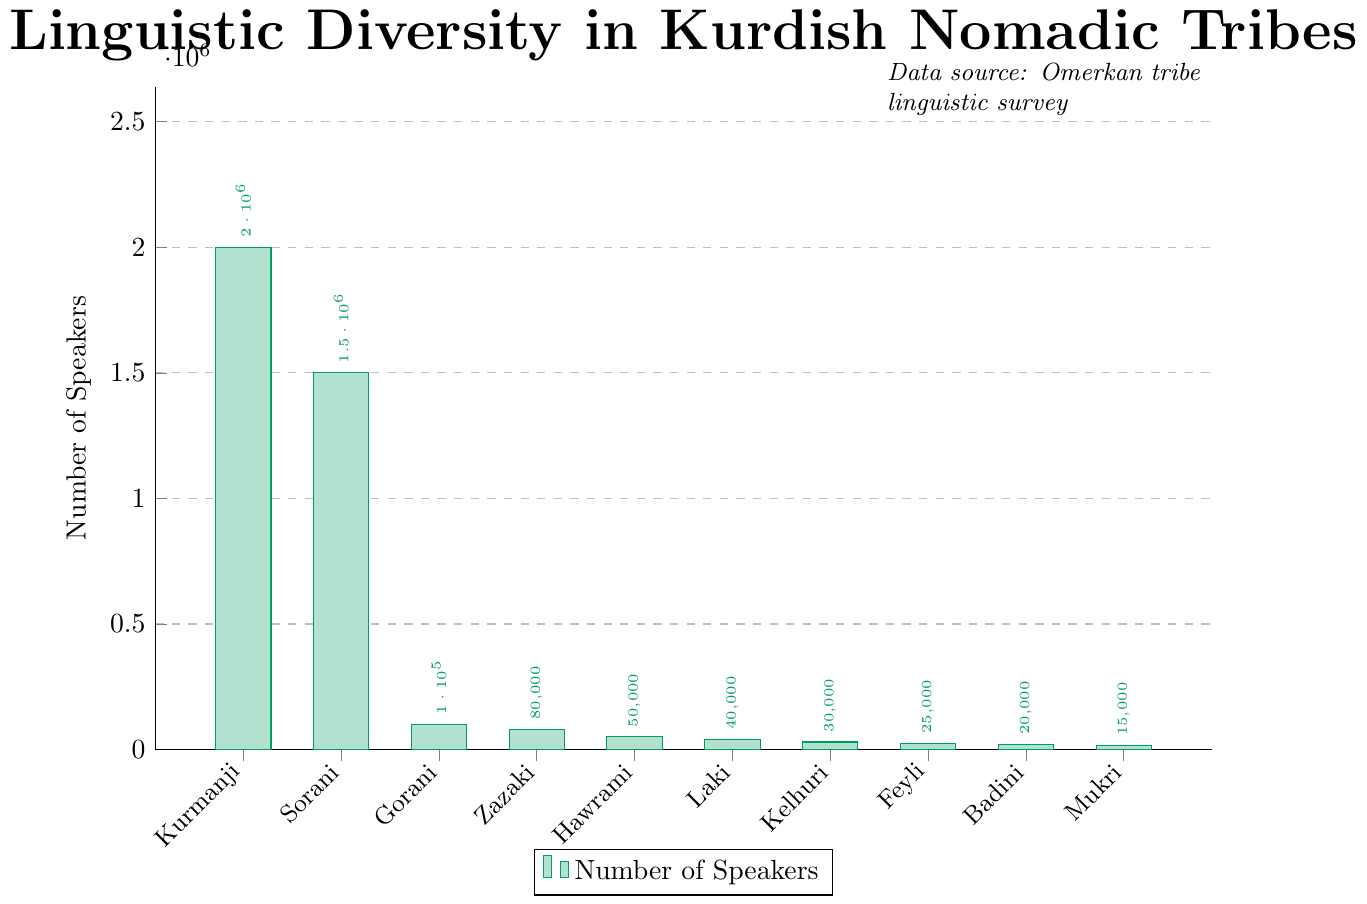Which dialect has the highest number of speakers? The bar representing Kurmanji is the tallest among all the bars, indicating it has the highest number of speakers.
Answer: Kurmanji How many more speakers does Sorani have compared to Gorani? The number of speakers for Sorani is 1,500,000, and for Gorani, it is 100,000. Subtracting Gorani's speakers from Sorani's gives 1,500,000 - 100,000.
Answer: 1,400,000 Which dialects have fewer than 50,000 speakers? The bars representing Hawrami, Laki, Kelhuri, Feyli, Badini, and Mukri are below the 50,000 mark on the y-axis.
Answer: Hawrami, Laki, Kelhuri, Feyli, Badini, Mukri What is the total number of speakers for the least spoken three dialects? The least spoken three dialects are Mukri, Badini, and Feyli with 15,000, 20,000, and 25,000 speakers respectively. Summing these values gives 15,000 + 20,000 + 25,000 = 60,000.
Answer: 60,000 Which dialect represents the second highest number of speakers? The bar representing Sorani is the second tallest after Kurmanji, indicating it has the second highest number of speakers.
Answer: Sorani Is the number of Gorani speakers greater than the combined speakers of Feyli and Mukri? Gorani has 100,000 speakers. Feyli has 25,000, and Mukri has 15,000. Combining Feyli and Mukri gives 25,000 + 15,000 = 40,000. Since 100,000 is greater than 40,000, the answer is yes.
Answer: Yes What is the average number of speakers for the dialects Hawrami, Laki, and Kelhuri? The number of speakers for Hawrami, Laki, and Kelhuri are 50,000, 40,000, and 30,000 respectively. Summing these and dividing by 3 gives (50,000 + 40,000 + 30,000)/3 = 120,000/3 = 40,000.
Answer: 40,000 Which dialects have a number of speakers between 20,000 and 100,000? The bars representing Gorani, Zazaki, Hawrami, Laki, and Kelhuri fall between the numeric values of 20,000 and 100,000 on the y-axis.
Answer: Gorani, Zazaki, Hawrami, Laki, Kelhuri 